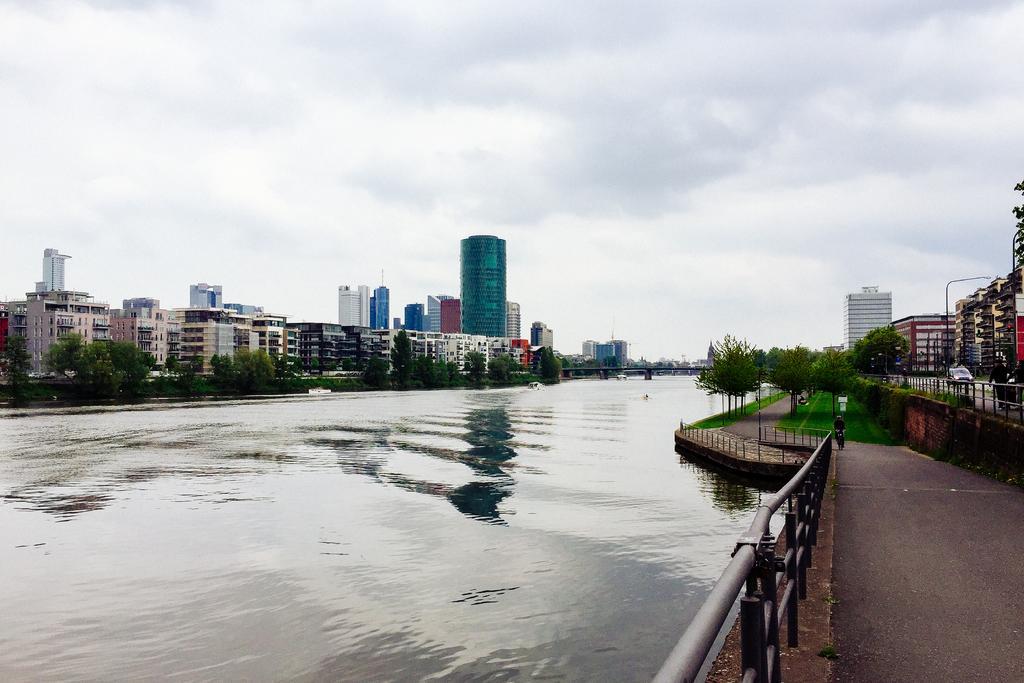How would you summarize this image in a sentence or two? In this picture there is water in the center of the image and there are vehicles and boundaries on the right side of the image and there are buildings, trees, and poles in the background area of the image. 